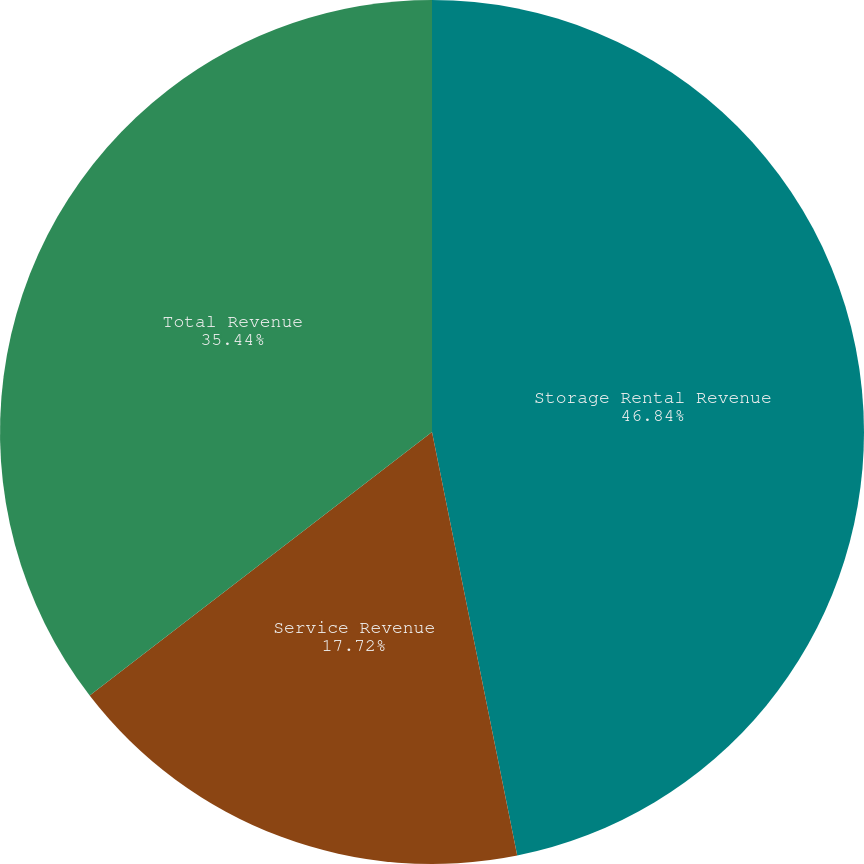Convert chart to OTSL. <chart><loc_0><loc_0><loc_500><loc_500><pie_chart><fcel>Storage Rental Revenue<fcel>Service Revenue<fcel>Total Revenue<nl><fcel>46.84%<fcel>17.72%<fcel>35.44%<nl></chart> 